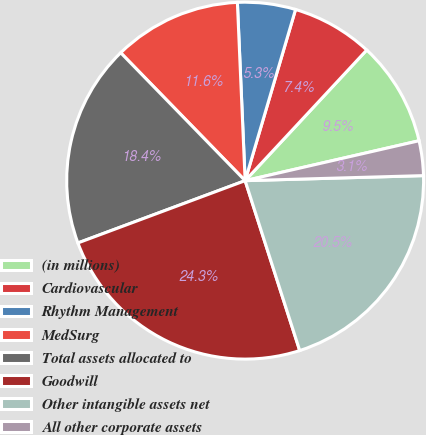<chart> <loc_0><loc_0><loc_500><loc_500><pie_chart><fcel>(in millions)<fcel>Cardiovascular<fcel>Rhythm Management<fcel>MedSurg<fcel>Total assets allocated to<fcel>Goodwill<fcel>Other intangible assets net<fcel>All other corporate assets<nl><fcel>9.48%<fcel>7.37%<fcel>5.25%<fcel>11.59%<fcel>18.39%<fcel>24.27%<fcel>20.5%<fcel>3.14%<nl></chart> 